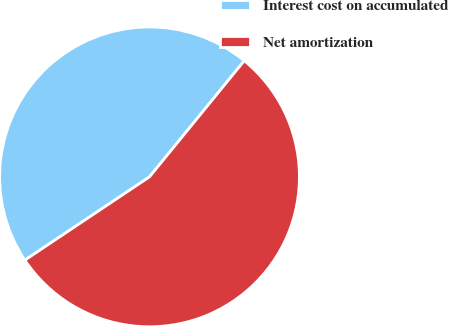Convert chart to OTSL. <chart><loc_0><loc_0><loc_500><loc_500><pie_chart><fcel>Interest cost on accumulated<fcel>Net amortization<nl><fcel>45.27%<fcel>54.73%<nl></chart> 